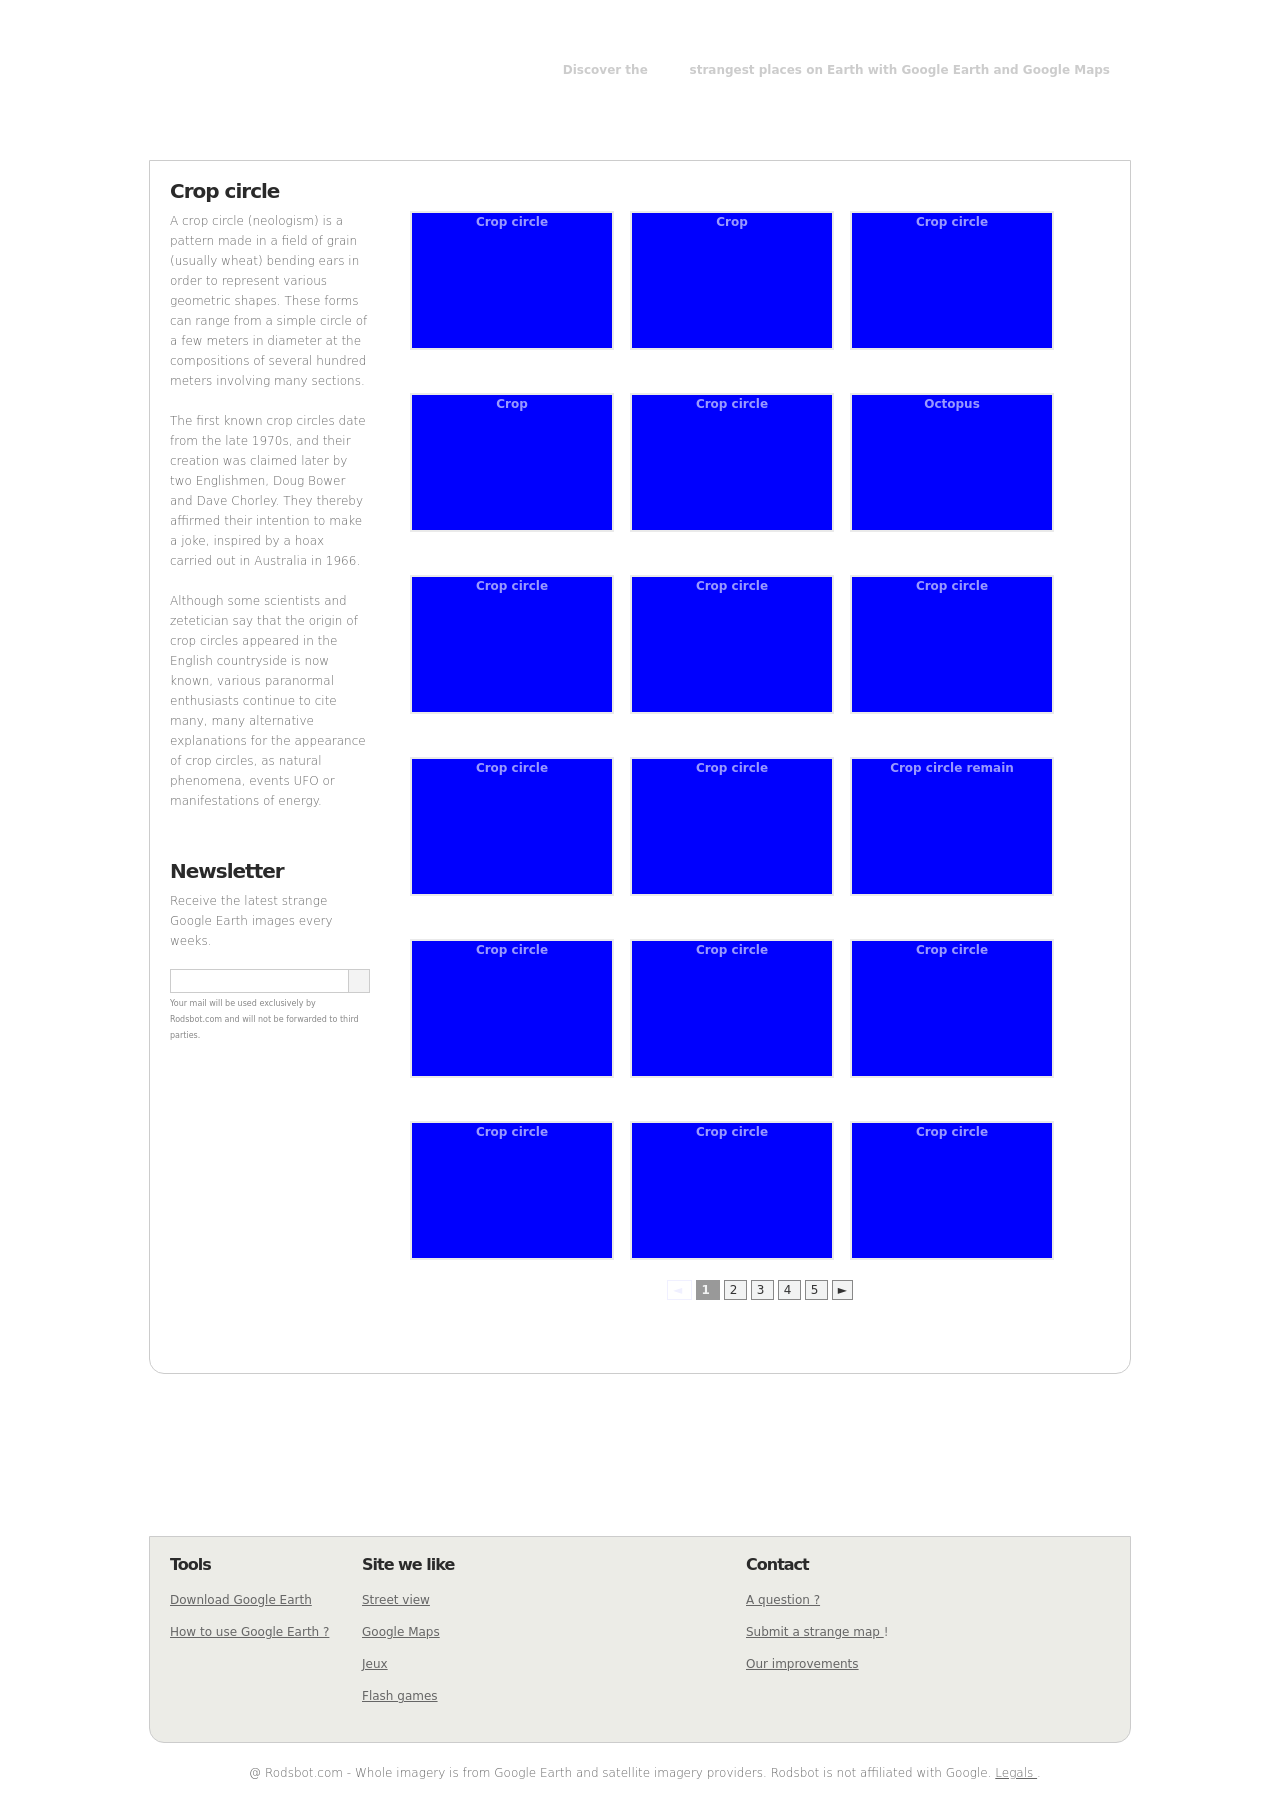Can you tell me more about the item labeled 'Octopus' in the image gallery? The item labeled 'Octopus' appears to be a creatively named crop circle. It likely references a unique design or pattern resembling an octopus, which is uncommon for crop circles typically characterized by geometric, simple shapes. This could be an artistic interpretation or a playful twist added to the usual crop circle designs seen in the gallery. 